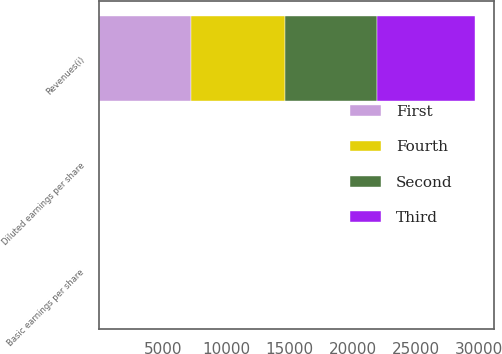Convert chart. <chart><loc_0><loc_0><loc_500><loc_500><stacked_bar_chart><ecel><fcel>Revenues(i)<fcel>Basic earnings per share<fcel>Diluted earnings per share<nl><fcel>Fourth<fcel>7406<fcel>0.54<fcel>0.52<nl><fcel>Second<fcel>7249<fcel>0.44<fcel>0.43<nl><fcel>First<fcel>7258<fcel>0.12<fcel>0.11<nl><fcel>Third<fcel>7769<fcel>4.43<fcel>4.25<nl></chart> 